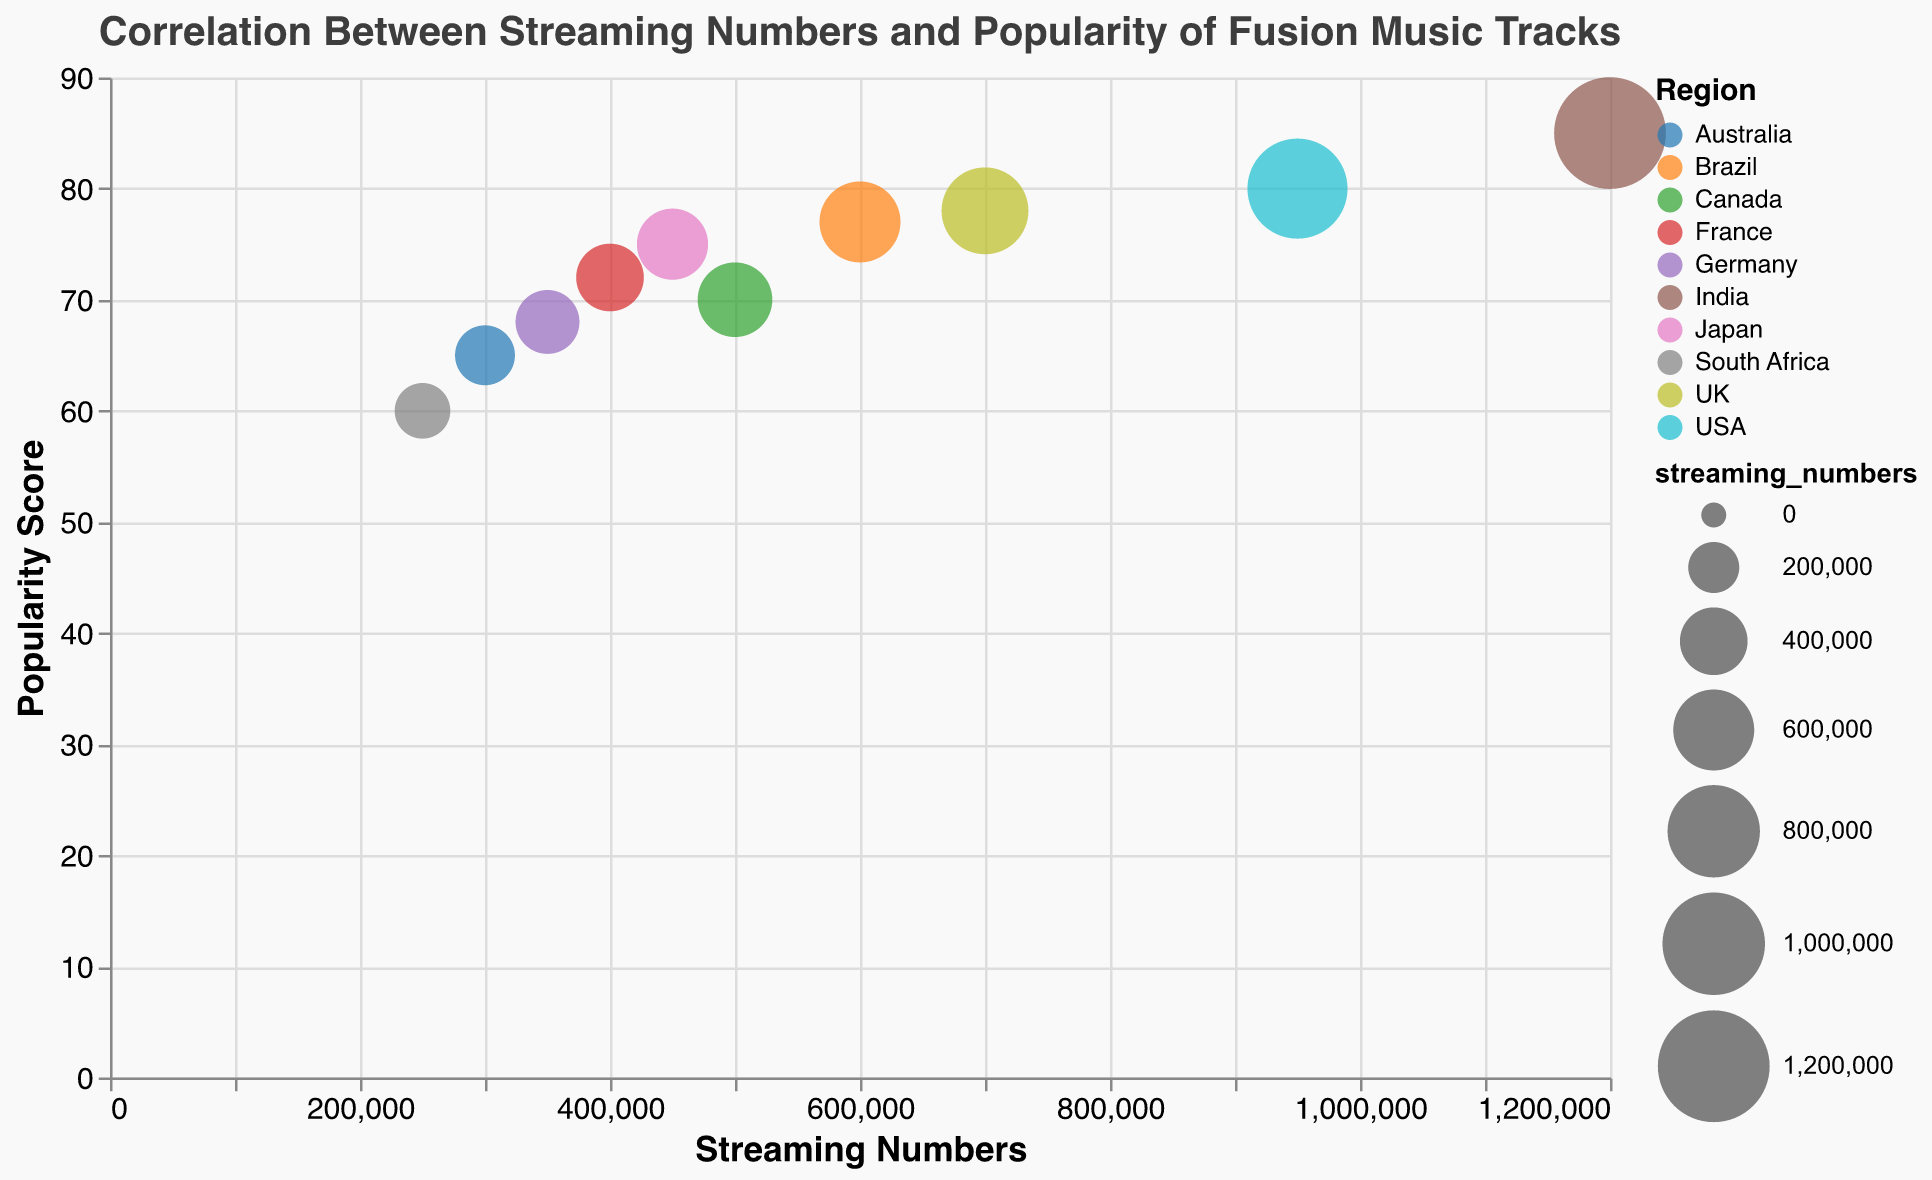What's the title of the figure? The title is typically found at the top of the figure and represents its main topic. In this case, it is "Correlation Between Streaming Numbers and Popularity of Fusion Music Tracks".
Answer: Correlation Between Streaming Numbers and Popularity of Fusion Music Tracks What do the colors represent in the figure? Colors are used to differentiate categories within the data. Here, the colors represent different geographical regions.
Answer: Geographical regions Which track has the highest streaming numbers, and what is its popularity score? By looking at the x-axis for the maximum value and identifying the corresponding bubble, we see that "Shakti Fusion" from India has the highest streaming numbers of 1,200,000 with a popularity score of 85.
Answer: Shakti Fusion, 85 Can you identify any trend between streaming numbers and popularity scores? Observing the scatter and the size of the bubbles, we see that higher streaming numbers tend to cluster with higher popularity scores, suggesting a positive correlation.
Answer: Positive correlation Which region has the lowest streaming numbers, and what is the track name? The smallest value on the x-axis corresponds to the track "Dhwani Dreams" from South Africa with 250,000 streaming numbers.
Answer: South Africa, Dhwani Dreams Compare the popularity scores of "Jazz Raga" and "Konnakol Beats". Locate the bubbles for "Jazz Raga" (Canada) and "Konnakol Beats" (Japan), and compare their positions on the y-axis. Jazz Raga has a popularity score of 70, while Konnakol Beats has a score of 75.
Answer: Jazz Raga: 70, Konnakol Beats: 75 What is the average popularity score for tracks with streaming numbers over 500,000? For tracks with streaming numbers over 500,000 ("Shakti Fusion", "Lotus Incantation", and "Raga Rock"), sum their popularity scores (85 + 80 + 77) and divide by 3.
Answer: (85 + 80 + 77) / 3 = 80.67 Explain the significance of bubble sizes in this chart. The bubble sizes represent the magnitude of the streaming numbers, with larger bubbles indicating higher streaming numbers. This visual cue helps to quickly identify tracks with the most streams.
Answer: Bubble sizes indicate streaming numbers Which track from Europe (Germany, France, UK) has the highest streaming numbers, and what is its popularity score? Identify the bubbles for tracks from Germany ("Bansuri Waves"), France ("Guitar Tala"), and UK ("Sitar Solstice"), then compare their streaming numbers. "Sitar Solstice" from the UK has the highest streaming numbers with a score of 700,000 and a popularity score of 78.
Answer: Sitar Solstice, 78 